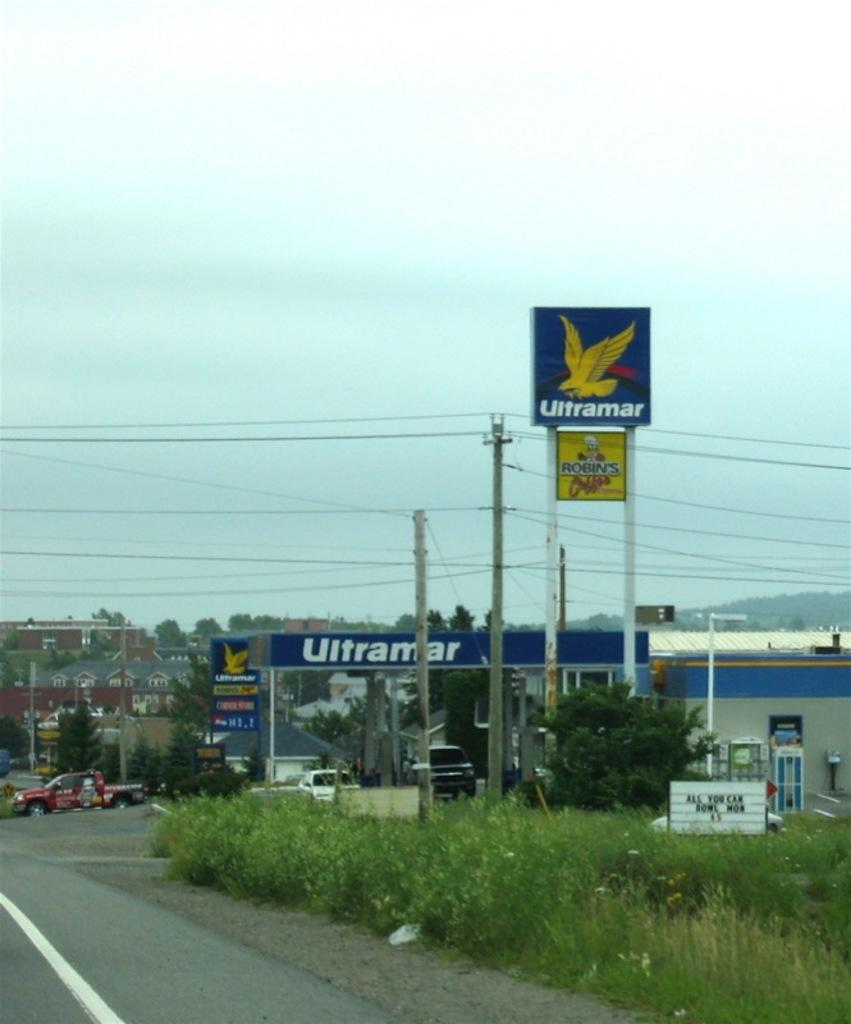<image>
Provide a brief description of the given image. A gas station has weeds growing around it and says Ultramar. 